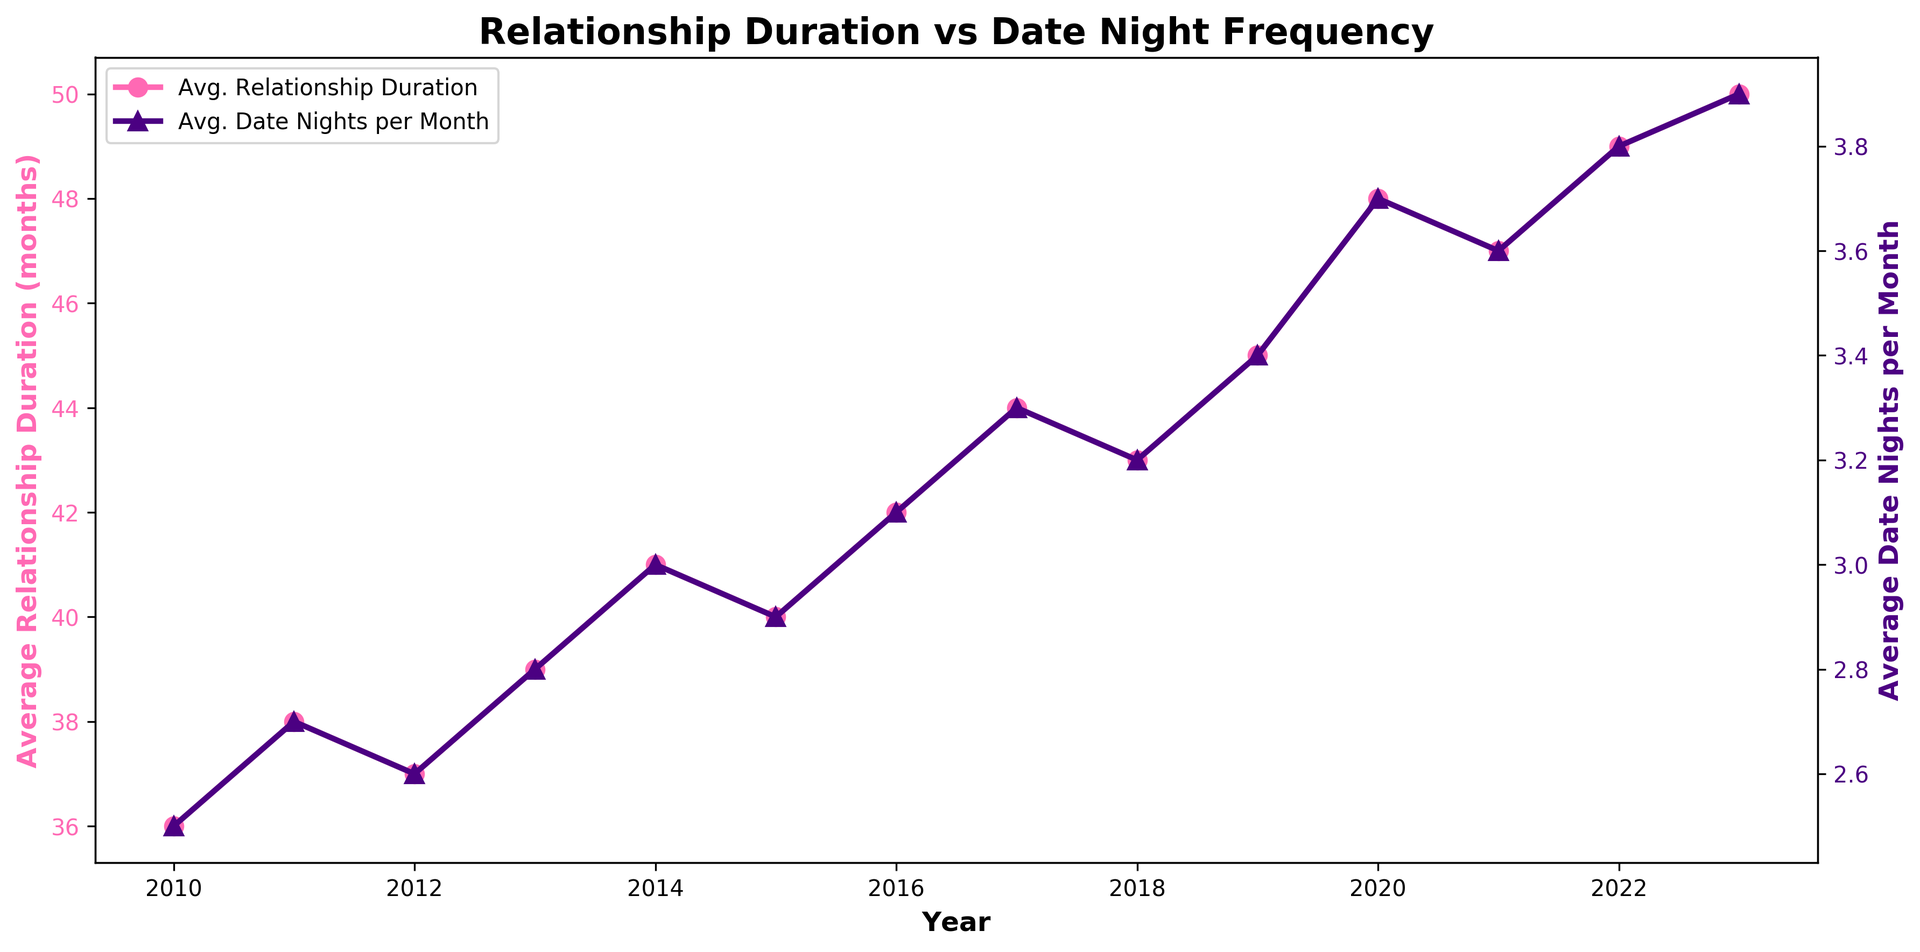What trend can you observe in the average relationship duration over the years? The chart indicates that the average relationship duration has generally increased from 2010 to 2023. This is shown by the upward trend of the pink line. From 36 months in 2010 to 50 months in 2023, the overall trend is positive.
Answer: An increasing trend in average relationship duration How did the average date nights per month change from 2014 to 2017? By examining the purple line in the chart, it's evident that the average date nights per month increased from 3.0 in 2014 to 3.3 in 2017. This upward movement illustrates a positive trend in the frequency of date nights during this period.
Answer: Increased from 3.0 to 3.3 Which year had the highest average date nights per month, and what was the value? The highest value on the purple line, representing the average date nights per month, occurs in 2023, where the data point reaches 3.9.
Answer: 2023, with 3.9 date nights per month Compare the growth in average relationship duration with the growth in average date nights per month over the entire period. From 2010 to 2023, the average relationship duration increased from 36 to 50 months, marking a growth of 14 months. During the same period, the average date nights per month increased from 2.5 to 3.9, a growth of 1.4 date nights per month. Though both metrics increased, the percentage growth in date nights (56%) is higher than that of relationship duration (39%).
Answer: Both increased, but date nights per month grew at a higher percentage In which year did the average relationship duration experience the most significant increase? By comparing the points on the pink line year by year, the largest single-year increase in average relationship duration appears between 2019 and 2020, jumping from 45 to 48 months.
Answer: Between 2019 and 2020 Is there a noticeable correlation between the average relationship duration and the average date nights per month? Both lines on the chart generally show an upward trend over the years. The parallel increase suggests a positive correlation where more frequent date nights might relate to longer relationship durations.
Answer: Yes, a positive correlation By how much did the average relationship duration and date nights per month increase from 2010 to 2023? The average relationship duration increased by 50 - 36 = 14 months. The average date nights per month increased by 3.9 - 2.5 = 1.4 date nights.
Answer: Relationship duration: 14 months; Date nights: 1.4 nights Which year shows a consistent increase in both metrics without any decline from the previous year? Both the pink and purple lines consistently increase from 2019 to 2022, with no declines.
Answer: 2020 to 2022 